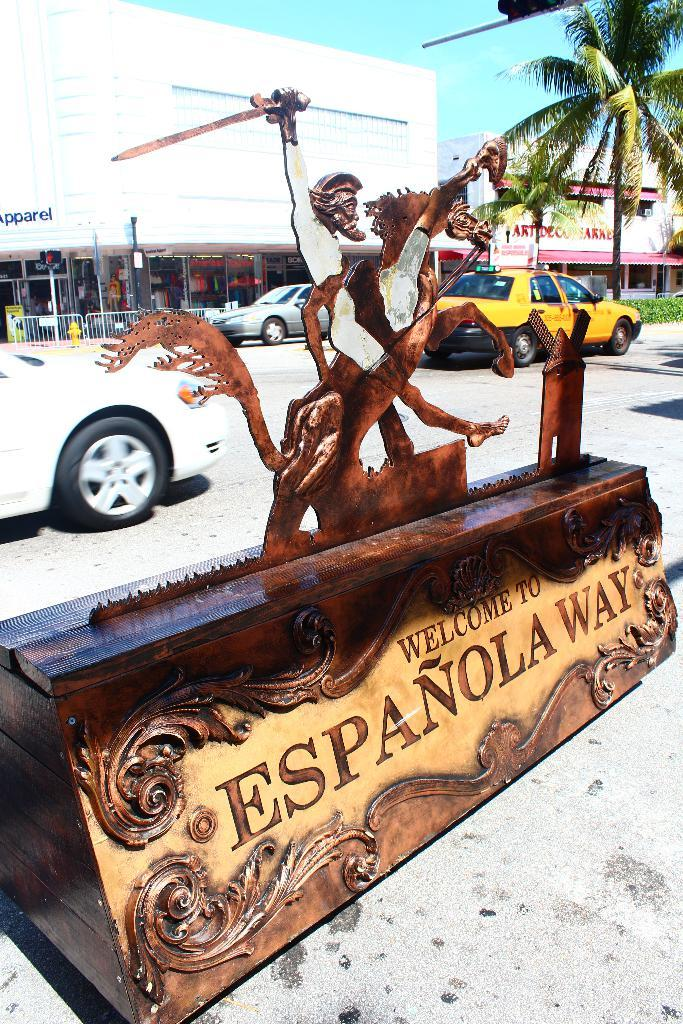<image>
Present a compact description of the photo's key features. A statue of a man riding a horse says Welcome To Espanola Way. 